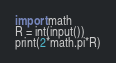Convert code to text. <code><loc_0><loc_0><loc_500><loc_500><_Python_>import math
R = int(input())
print(2*math.pi*R)</code> 